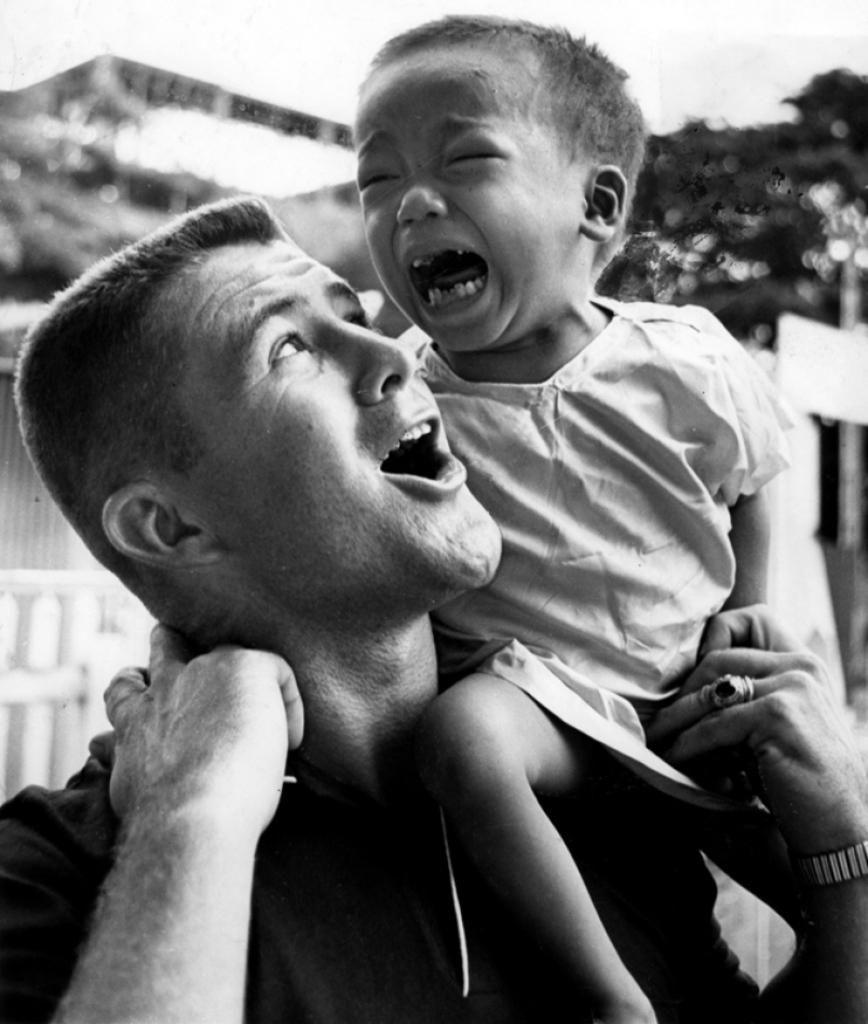How many people are present in the image? There are two persons in the image. What can be seen in the background of the image? There are trees and buildings in the background of the image. What is the color scheme of the image? The image is in black and white. What type of yard can be seen in the image? There is no yard present in the image; it features two persons and a background with trees and buildings. 